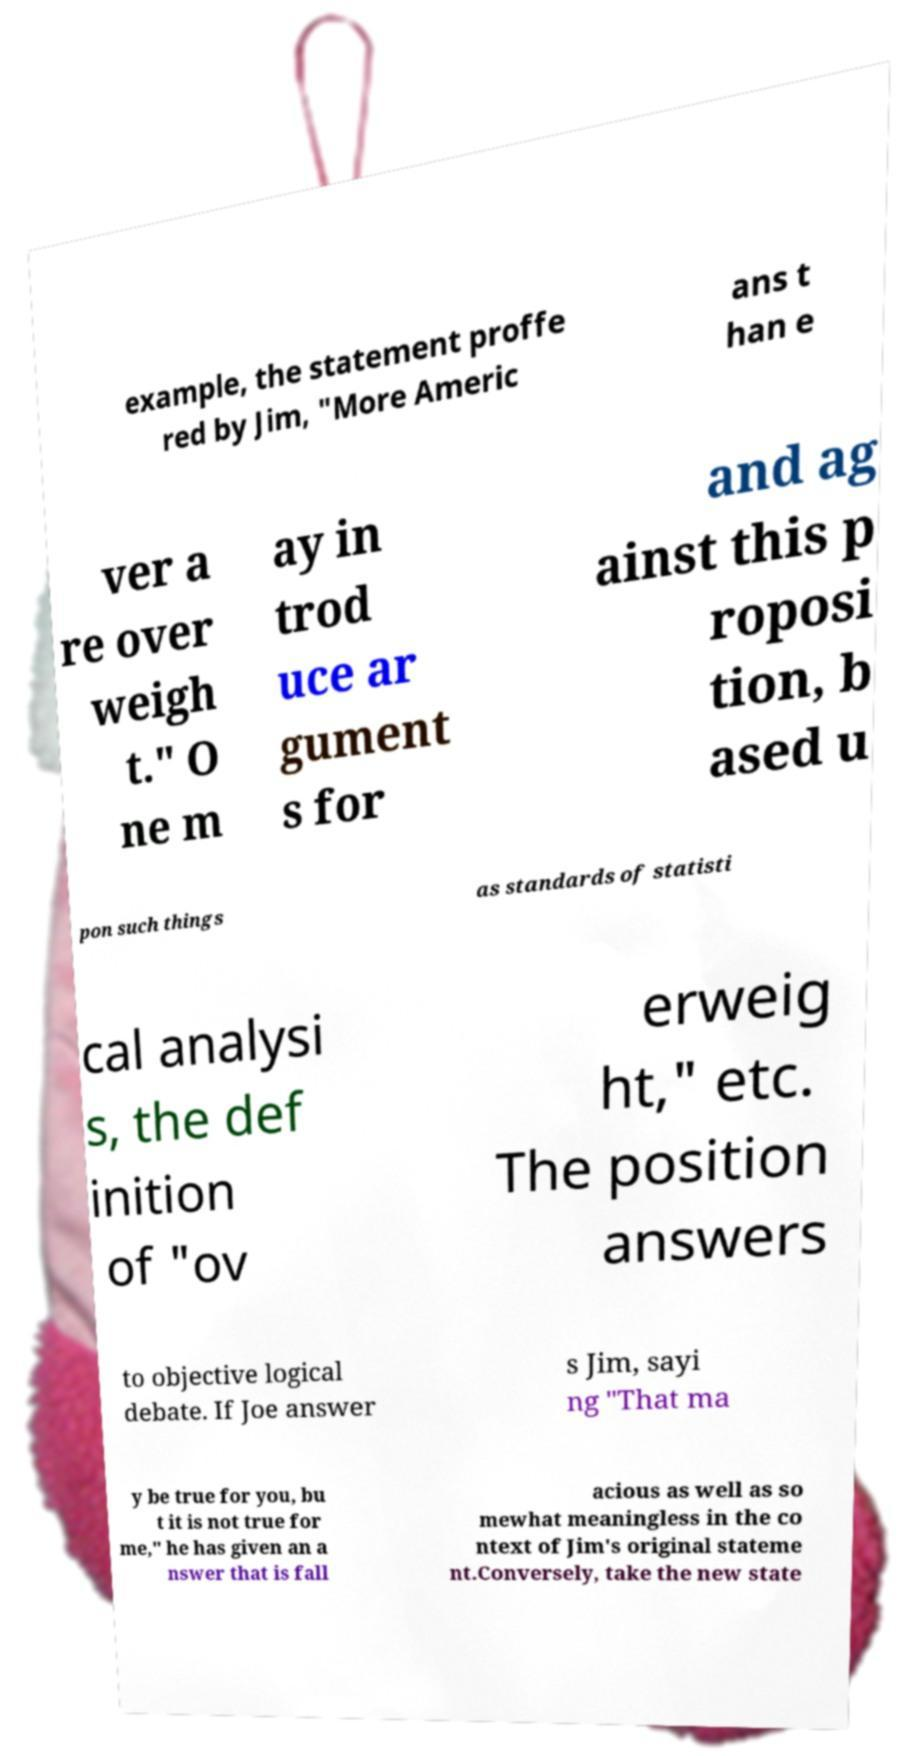Could you assist in decoding the text presented in this image and type it out clearly? example, the statement proffe red by Jim, "More Americ ans t han e ver a re over weigh t." O ne m ay in trod uce ar gument s for and ag ainst this p roposi tion, b ased u pon such things as standards of statisti cal analysi s, the def inition of "ov erweig ht," etc. The position answers to objective logical debate. If Joe answer s Jim, sayi ng "That ma y be true for you, bu t it is not true for me," he has given an a nswer that is fall acious as well as so mewhat meaningless in the co ntext of Jim's original stateme nt.Conversely, take the new state 